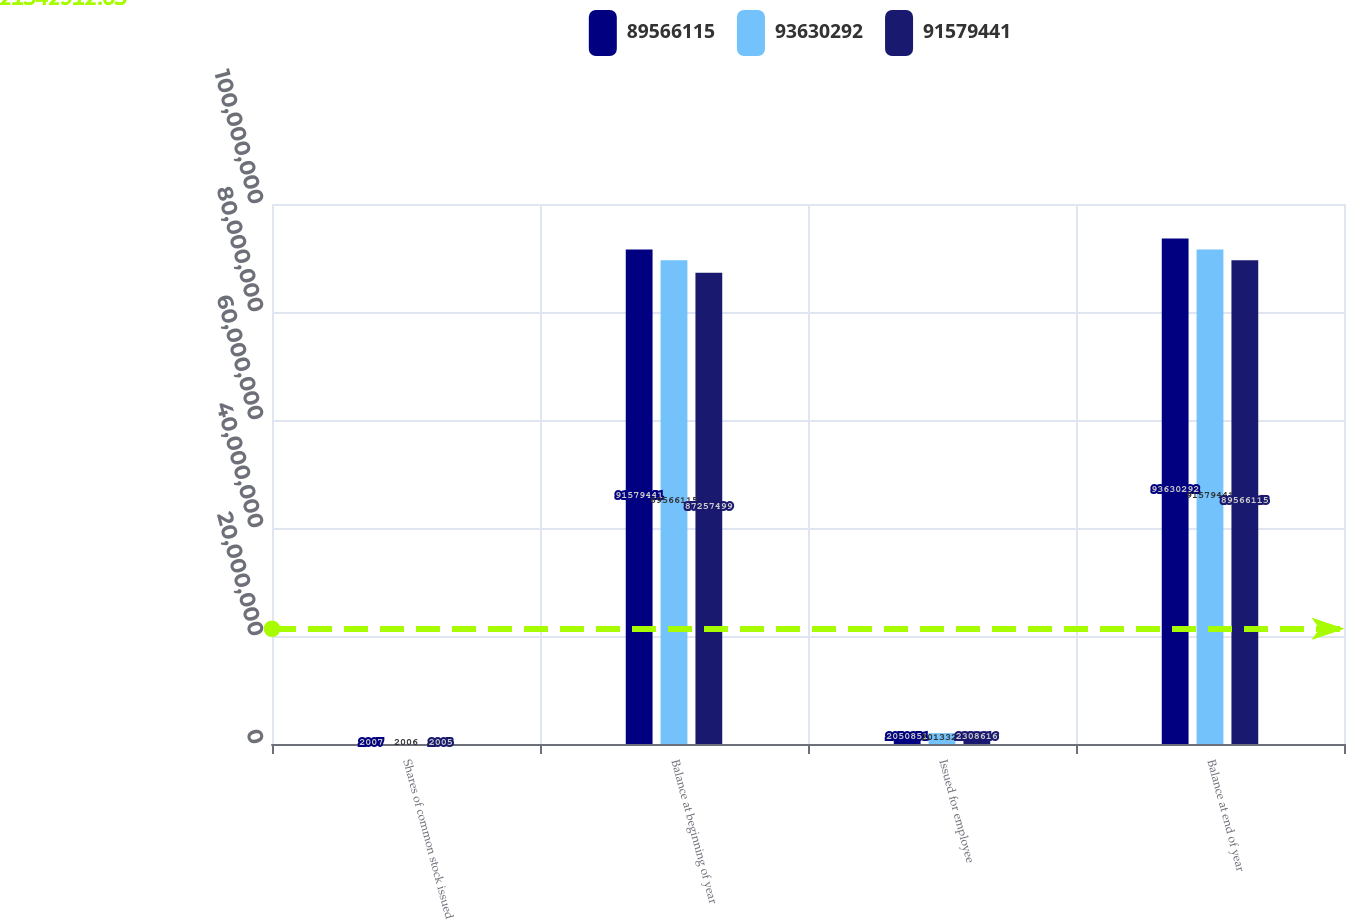Convert chart to OTSL. <chart><loc_0><loc_0><loc_500><loc_500><stacked_bar_chart><ecel><fcel>Shares of common stock issued<fcel>Balance at beginning of year<fcel>Issued for employee<fcel>Balance at end of year<nl><fcel>8.95661e+07<fcel>2007<fcel>9.15794e+07<fcel>2.05085e+06<fcel>9.36303e+07<nl><fcel>9.36303e+07<fcel>2006<fcel>8.95661e+07<fcel>2.01333e+06<fcel>9.15794e+07<nl><fcel>9.15794e+07<fcel>2005<fcel>8.72575e+07<fcel>2.30862e+06<fcel>8.95661e+07<nl></chart> 